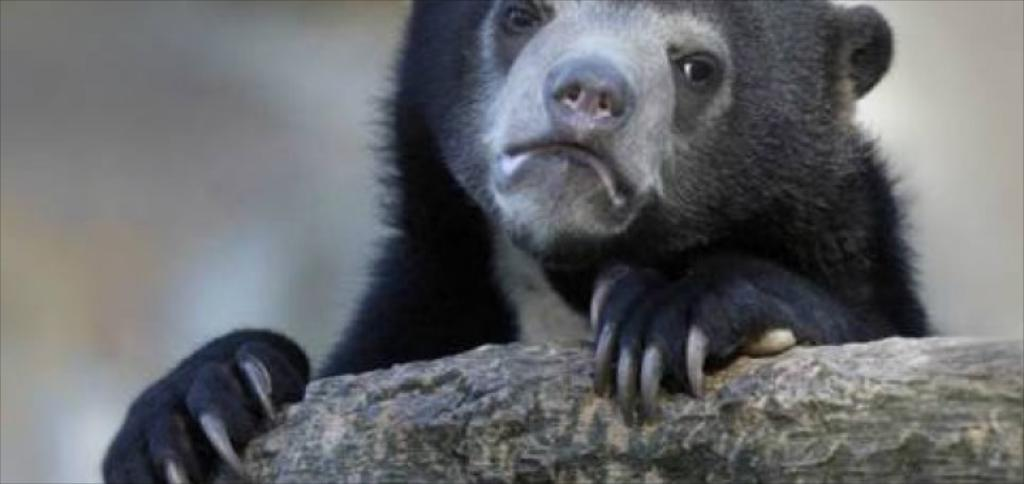What type of creature is present in the image? There is an animal in the image. What is the animal doing in the image? The animal is holding an object. Can you describe the background of the image? The background of the image is blurred. Where is the animal's partner located in the image? There is no mention of a partner in the image, so it cannot be determined where a partner might be located. 